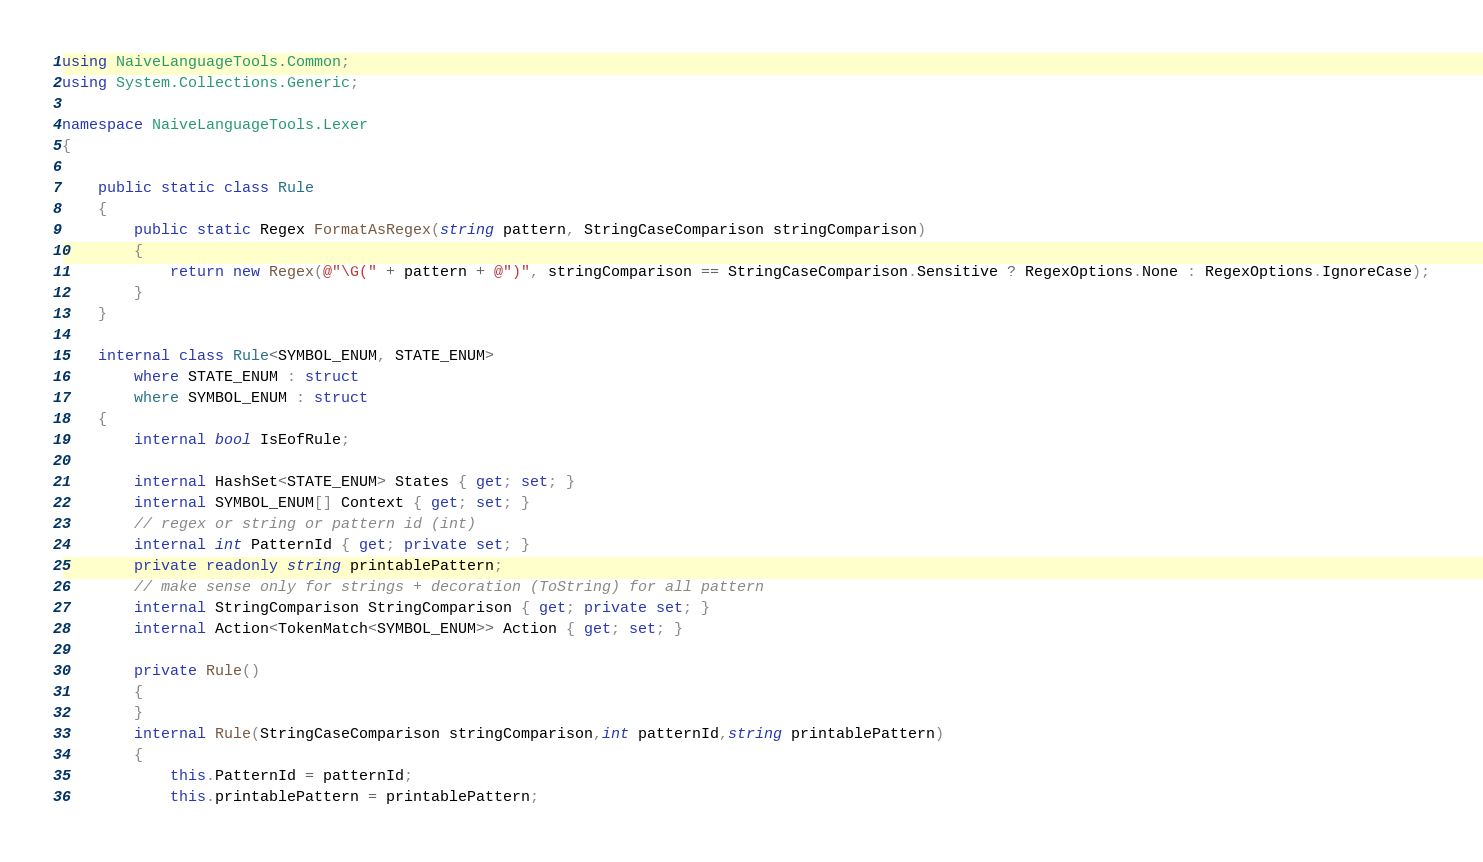Convert code to text. <code><loc_0><loc_0><loc_500><loc_500><_C#_>using NaiveLanguageTools.Common;
using System.Collections.Generic;

namespace NaiveLanguageTools.Lexer
{

    public static class Rule
    {
        public static Regex FormatAsRegex(string pattern, StringCaseComparison stringComparison)
        {
            return new Regex(@"\G(" + pattern + @")", stringComparison == StringCaseComparison.Sensitive ? RegexOptions.None : RegexOptions.IgnoreCase);
        }
    }

    internal class Rule<SYMBOL_ENUM, STATE_ENUM>
        where STATE_ENUM : struct
        where SYMBOL_ENUM : struct
    {
        internal bool IsEofRule;

        internal HashSet<STATE_ENUM> States { get; set; }
        internal SYMBOL_ENUM[] Context { get; set; }
        // regex or string or pattern id (int)
        internal int PatternId { get; private set; }
        private readonly string printablePattern;
        // make sense only for strings + decoration (ToString) for all pattern
        internal StringComparison StringComparison { get; private set; }
        internal Action<TokenMatch<SYMBOL_ENUM>> Action { get; set; }

        private Rule()
        {
        }
        internal Rule(StringCaseComparison stringComparison,int patternId,string printablePattern)
        {
            this.PatternId = patternId;
            this.printablePattern = printablePattern;</code> 